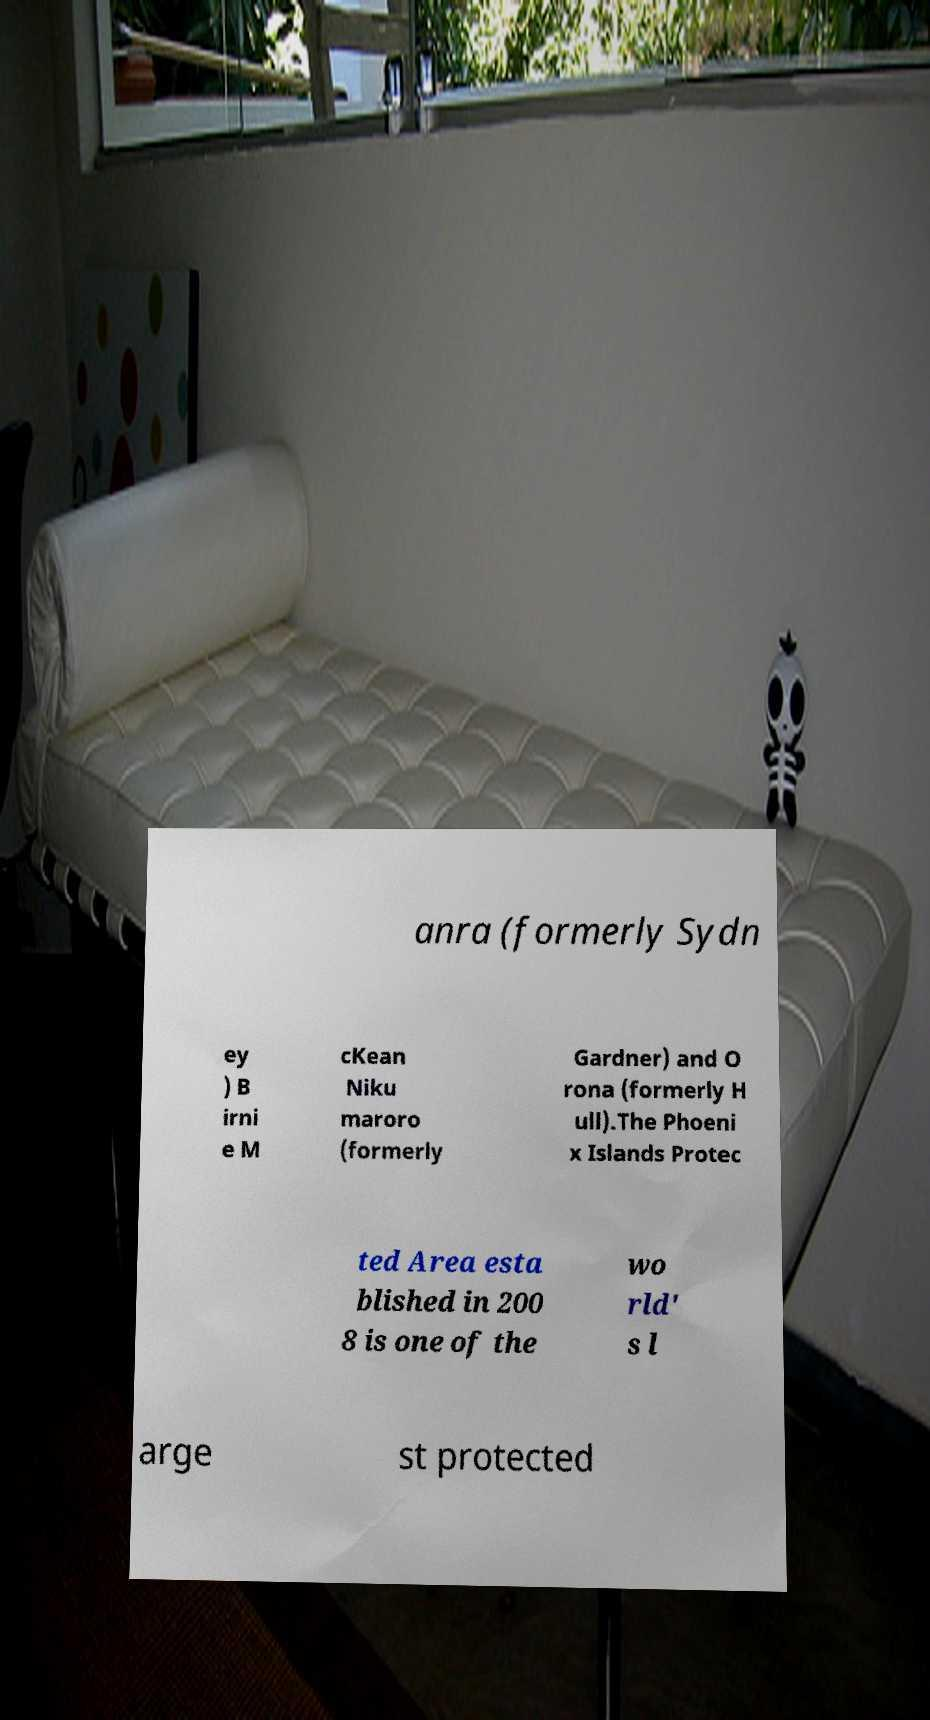I need the written content from this picture converted into text. Can you do that? anra (formerly Sydn ey ) B irni e M cKean Niku maroro (formerly Gardner) and O rona (formerly H ull).The Phoeni x Islands Protec ted Area esta blished in 200 8 is one of the wo rld' s l arge st protected 